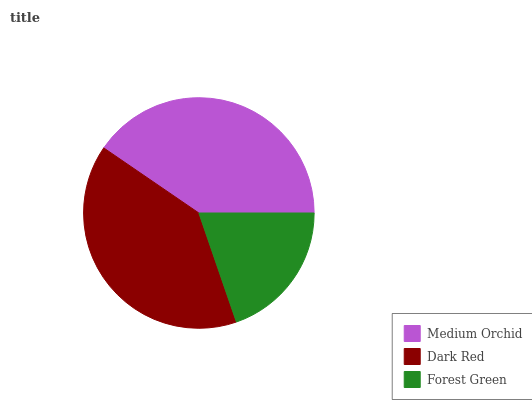Is Forest Green the minimum?
Answer yes or no. Yes. Is Medium Orchid the maximum?
Answer yes or no. Yes. Is Dark Red the minimum?
Answer yes or no. No. Is Dark Red the maximum?
Answer yes or no. No. Is Medium Orchid greater than Dark Red?
Answer yes or no. Yes. Is Dark Red less than Medium Orchid?
Answer yes or no. Yes. Is Dark Red greater than Medium Orchid?
Answer yes or no. No. Is Medium Orchid less than Dark Red?
Answer yes or no. No. Is Dark Red the high median?
Answer yes or no. Yes. Is Dark Red the low median?
Answer yes or no. Yes. Is Forest Green the high median?
Answer yes or no. No. Is Medium Orchid the low median?
Answer yes or no. No. 